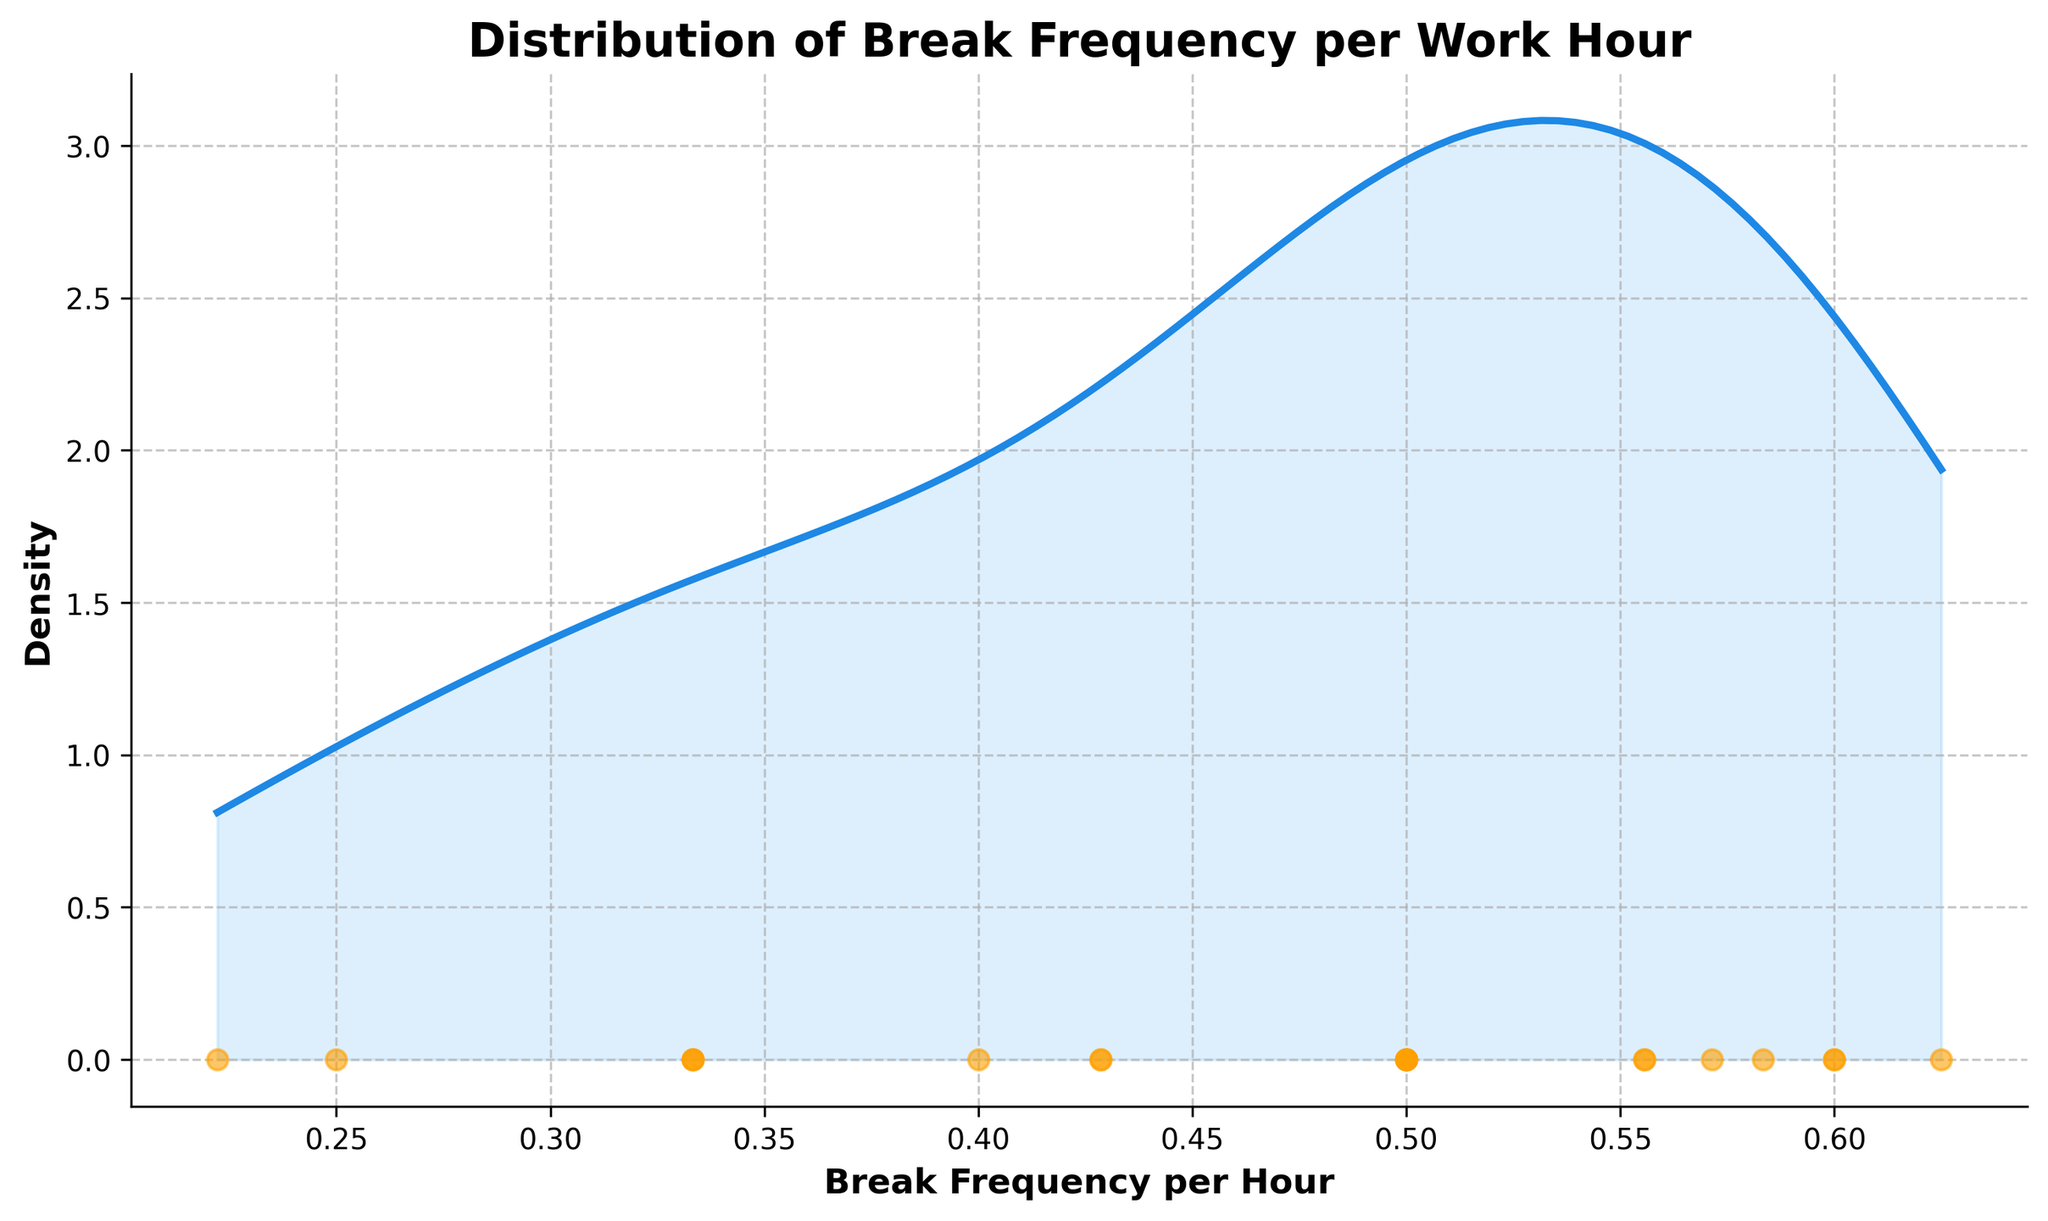What is the title of the plot? The title is displayed at the top and is clearly indicating the focus of the plot.
Answer: Distribution of Break Frequency per Work Hour What is the x-axis label? The x-axis label is directly on the x-axis and states what the horizontal axis represents.
Answer: Break Frequency per Hour How many data points are there in the plot? There is a scatter plot at the bottom of the density plot, each data point represents a user. By counting the scatter points, we can determine the number of data points.
Answer: 20 What does the y-axis represent? The y-axis label is on the left and shows what the vertical axis measures.
Answer: Density Which visual element uses blue color with shaded fill? The blue line with a shaded fill area under it represents the density estimation of the break frequency per hour.
Answer: Density curve How is the actual data represented in the plot? The actual data points are plotted as individual points at the bottom of the density plot. Each point represents a user's break frequency per hour. The points are colored and scattered along the x-axis.
Answer: Scatter plot of points at the bottom Where does the peak of the density curve occur on the x-axis? By looking at the highest point on the y-axis of the density curve, we can trace it down to find the corresponding x-axis value, which shows where the break frequency per hour is most frequent among users.
Answer: Approximately around 0.5 Is there a data point with a break frequency per hour close to 0.7? By scanning the scatter points along the x-axis, we can identify if any points are situated around the 0.7 mark.
Answer: Yes Does the density curve have multiple peaks? To determine this, we examine the density curve to see if there are more than one distinct high points on the y-axis.
Answer: No Which side of the plot (left or right) has more density? By comparing the overall area under the density curve on both sides of the plot, we can see which side has more density.
Answer: Left Summarize the general trend indicated by the density curve. The density curve shows how break frequency per work hour is distributed among users. By examining the shape and skew of the curve, we can understand if most users have lower, average, or higher break frequencies per hour.
Answer: Most users have break frequencies per hour around 0.5, with fewer users having much higher or lower frequencies 